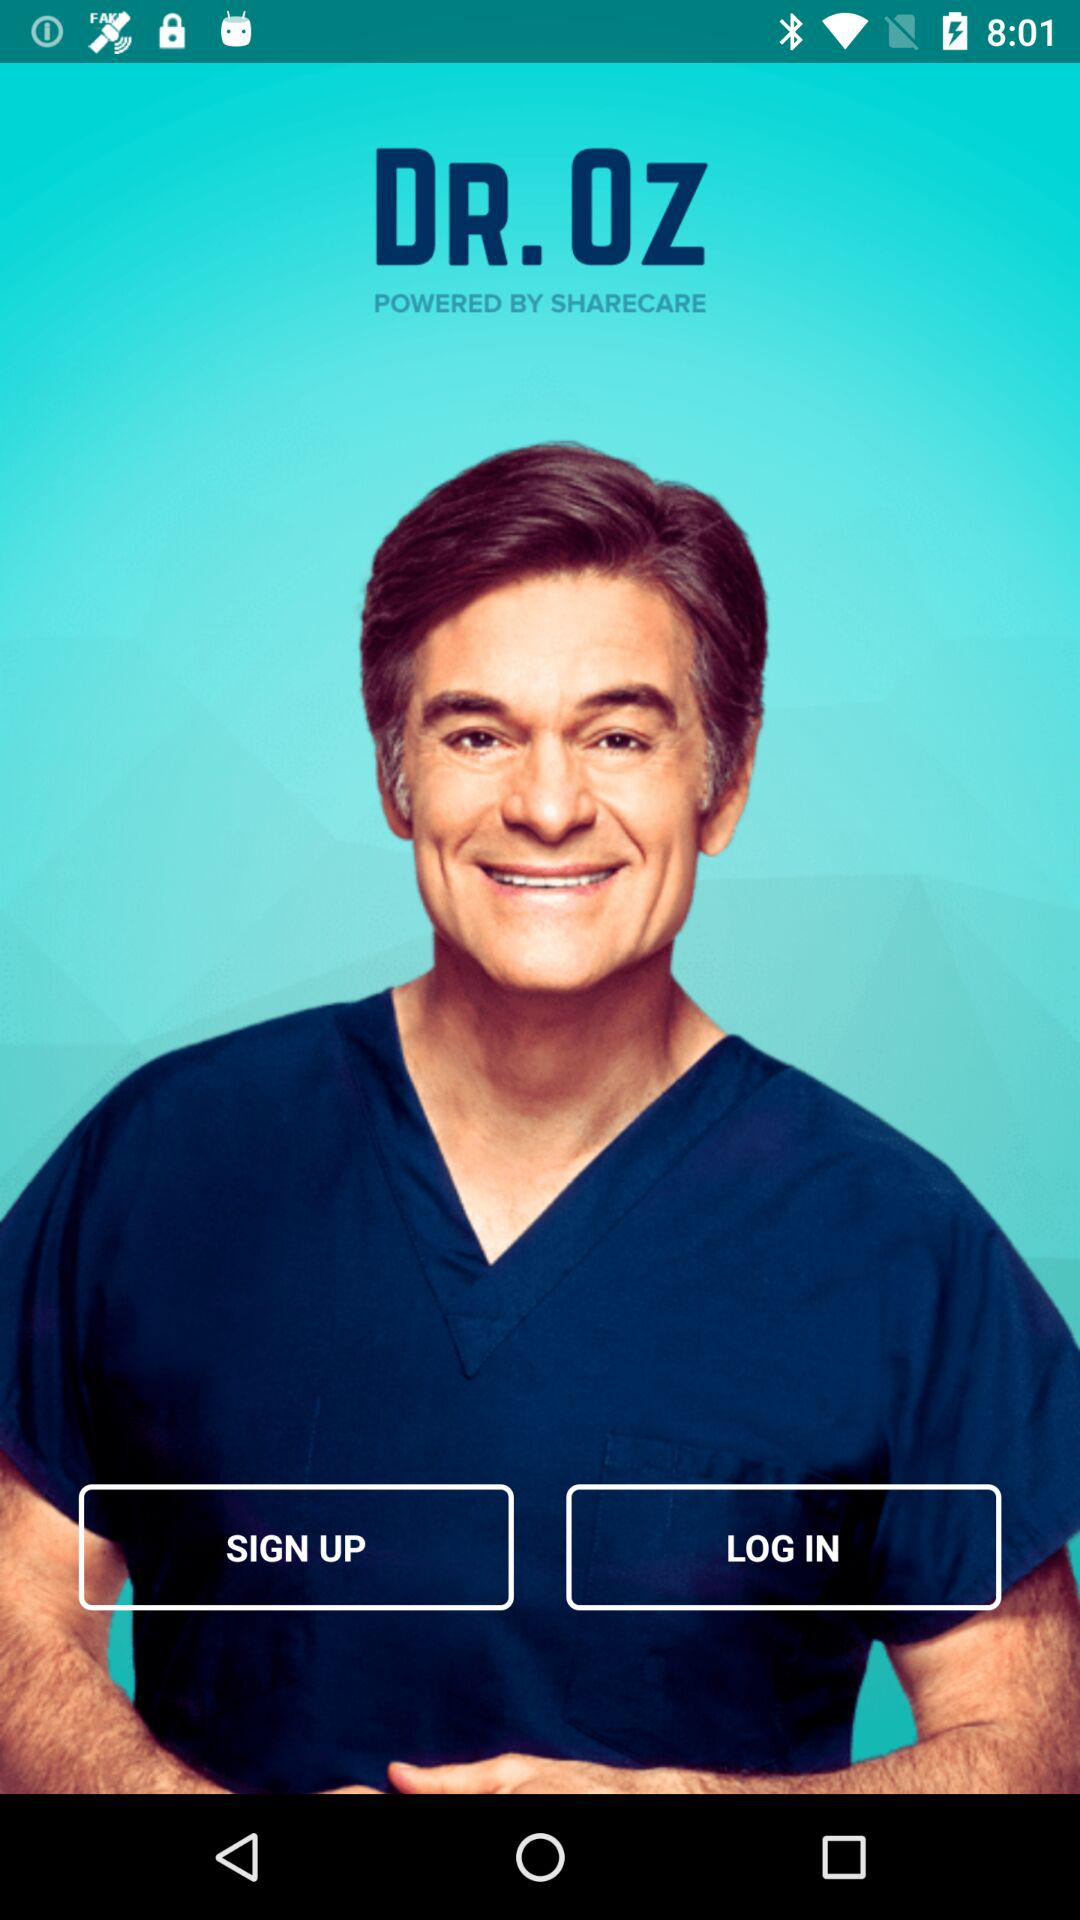What is the application name? The application name is "DR. OZ". 